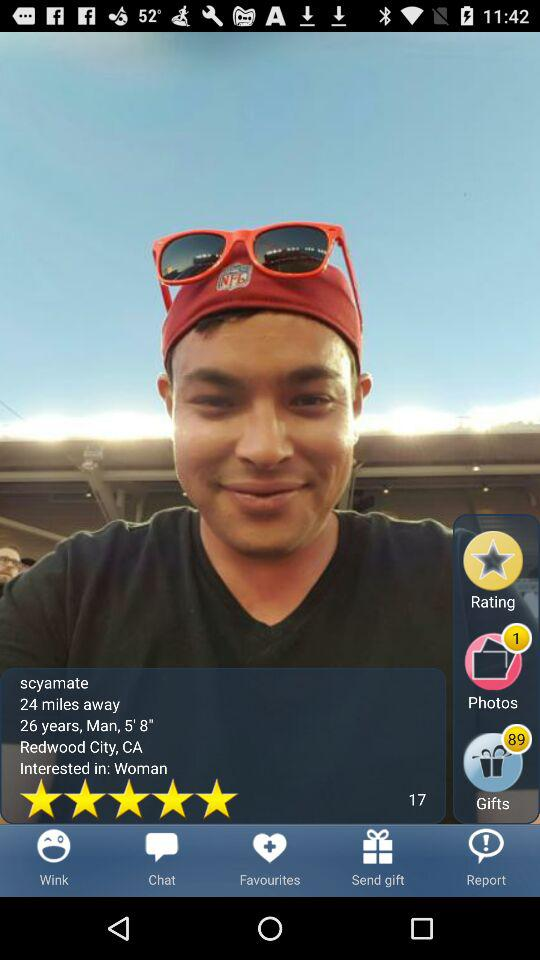What location does the Scyamate belong to? The Scyamate belongs to Redwood City, CA. 